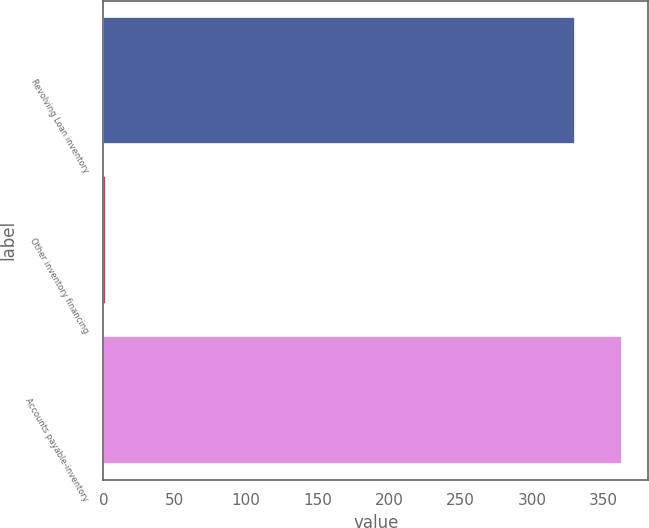Convert chart. <chart><loc_0><loc_0><loc_500><loc_500><bar_chart><fcel>Revolving Loan inventory<fcel>Other inventory financing<fcel>Accounts payable-inventory<nl><fcel>330.1<fcel>2<fcel>363.11<nl></chart> 